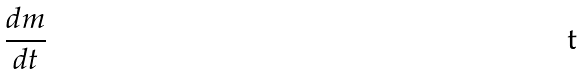Convert formula to latex. <formula><loc_0><loc_0><loc_500><loc_500>\frac { d m } { d t }</formula> 